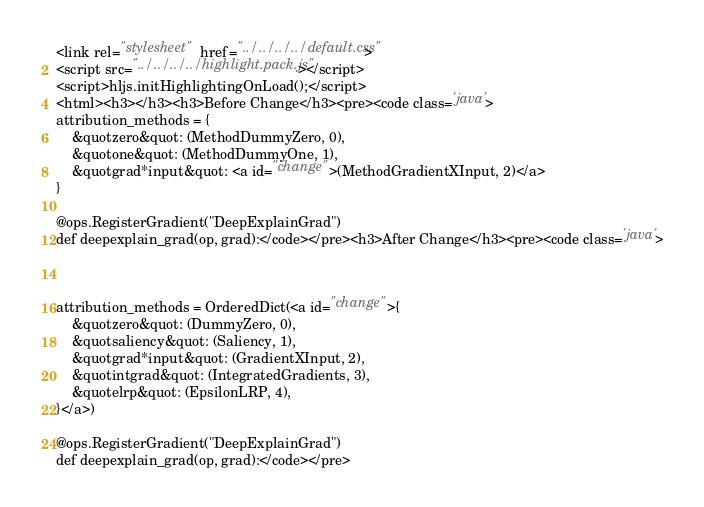Convert code to text. <code><loc_0><loc_0><loc_500><loc_500><_HTML_><link rel="stylesheet" href="../../../../default.css">
<script src="../../../../highlight.pack.js"></script> 
<script>hljs.initHighlightingOnLoad();</script>
<html><h3></h3><h3>Before Change</h3><pre><code class='java'>
attribution_methods = {
    &quotzero&quot: (MethodDummyZero, 0),
    &quotone&quot: (MethodDummyOne, 1),
    &quotgrad*input&quot: <a id="change">(MethodGradientXInput, 2)</a>
}

@ops.RegisterGradient("DeepExplainGrad")
def deepexplain_grad(op, grad):</code></pre><h3>After Change</h3><pre><code class='java'>



attribution_methods = OrderedDict(<a id="change">{
    &quotzero&quot: (DummyZero, 0),
    &quotsaliency&quot: (Saliency, 1),
    &quotgrad*input&quot: (GradientXInput, 2),
    &quotintgrad&quot: (IntegratedGradients, 3),
    &quotelrp&quot: (EpsilonLRP, 4),
}</a>)

@ops.RegisterGradient("DeepExplainGrad")
def deepexplain_grad(op, grad):</code></pre></code> 